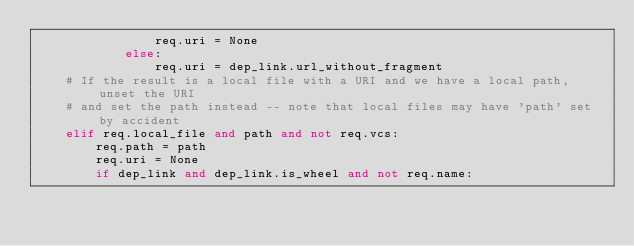<code> <loc_0><loc_0><loc_500><loc_500><_Python_>                req.uri = None
            else:
                req.uri = dep_link.url_without_fragment
    # If the result is a local file with a URI and we have a local path, unset the URI
    # and set the path instead -- note that local files may have 'path' set by accident
    elif req.local_file and path and not req.vcs:
        req.path = path
        req.uri = None
        if dep_link and dep_link.is_wheel and not req.name:</code> 